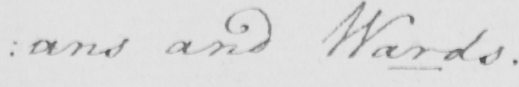Can you read and transcribe this handwriting? : ans and Wards . 